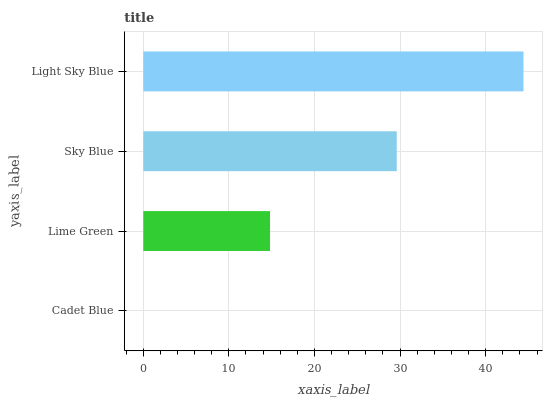Is Cadet Blue the minimum?
Answer yes or no. Yes. Is Light Sky Blue the maximum?
Answer yes or no. Yes. Is Lime Green the minimum?
Answer yes or no. No. Is Lime Green the maximum?
Answer yes or no. No. Is Lime Green greater than Cadet Blue?
Answer yes or no. Yes. Is Cadet Blue less than Lime Green?
Answer yes or no. Yes. Is Cadet Blue greater than Lime Green?
Answer yes or no. No. Is Lime Green less than Cadet Blue?
Answer yes or no. No. Is Sky Blue the high median?
Answer yes or no. Yes. Is Lime Green the low median?
Answer yes or no. Yes. Is Cadet Blue the high median?
Answer yes or no. No. Is Sky Blue the low median?
Answer yes or no. No. 